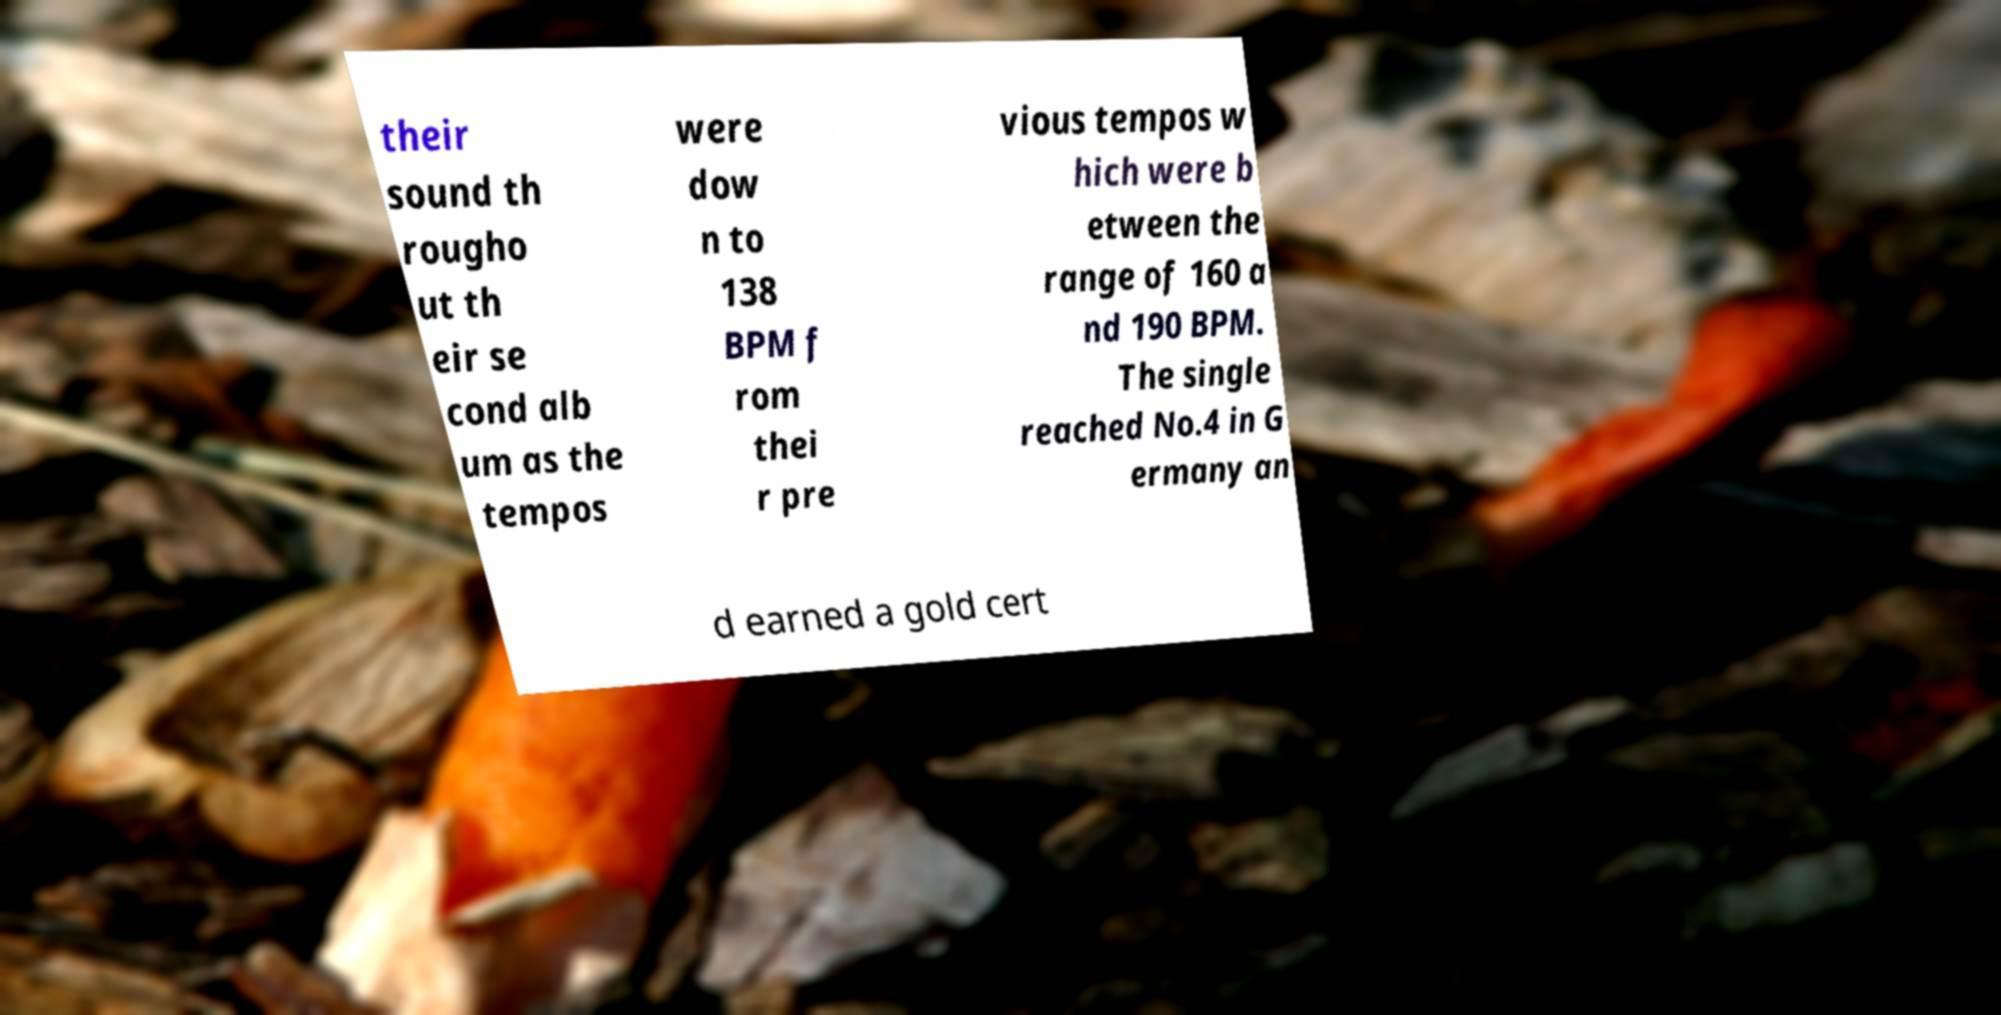For documentation purposes, I need the text within this image transcribed. Could you provide that? their sound th rougho ut th eir se cond alb um as the tempos were dow n to 138 BPM f rom thei r pre vious tempos w hich were b etween the range of 160 a nd 190 BPM. The single reached No.4 in G ermany an d earned a gold cert 